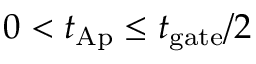<formula> <loc_0><loc_0><loc_500><loc_500>0 < t _ { A p } \leq t _ { g a t e } / { 2 }</formula> 